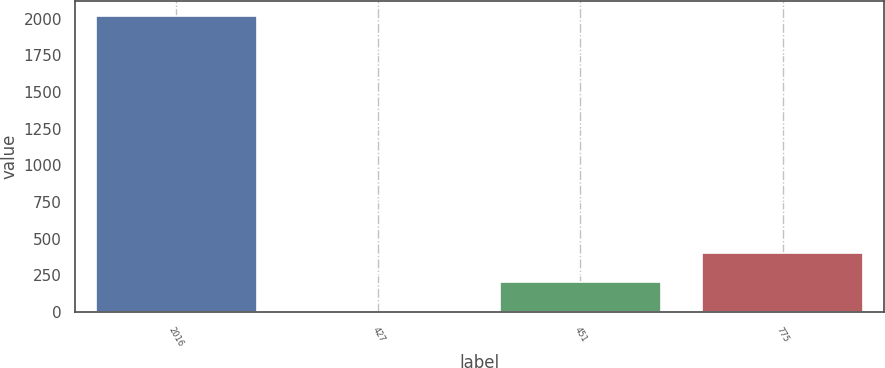<chart> <loc_0><loc_0><loc_500><loc_500><bar_chart><fcel>2016<fcel>427<fcel>451<fcel>775<nl><fcel>2016<fcel>2.33<fcel>203.7<fcel>405.07<nl></chart> 